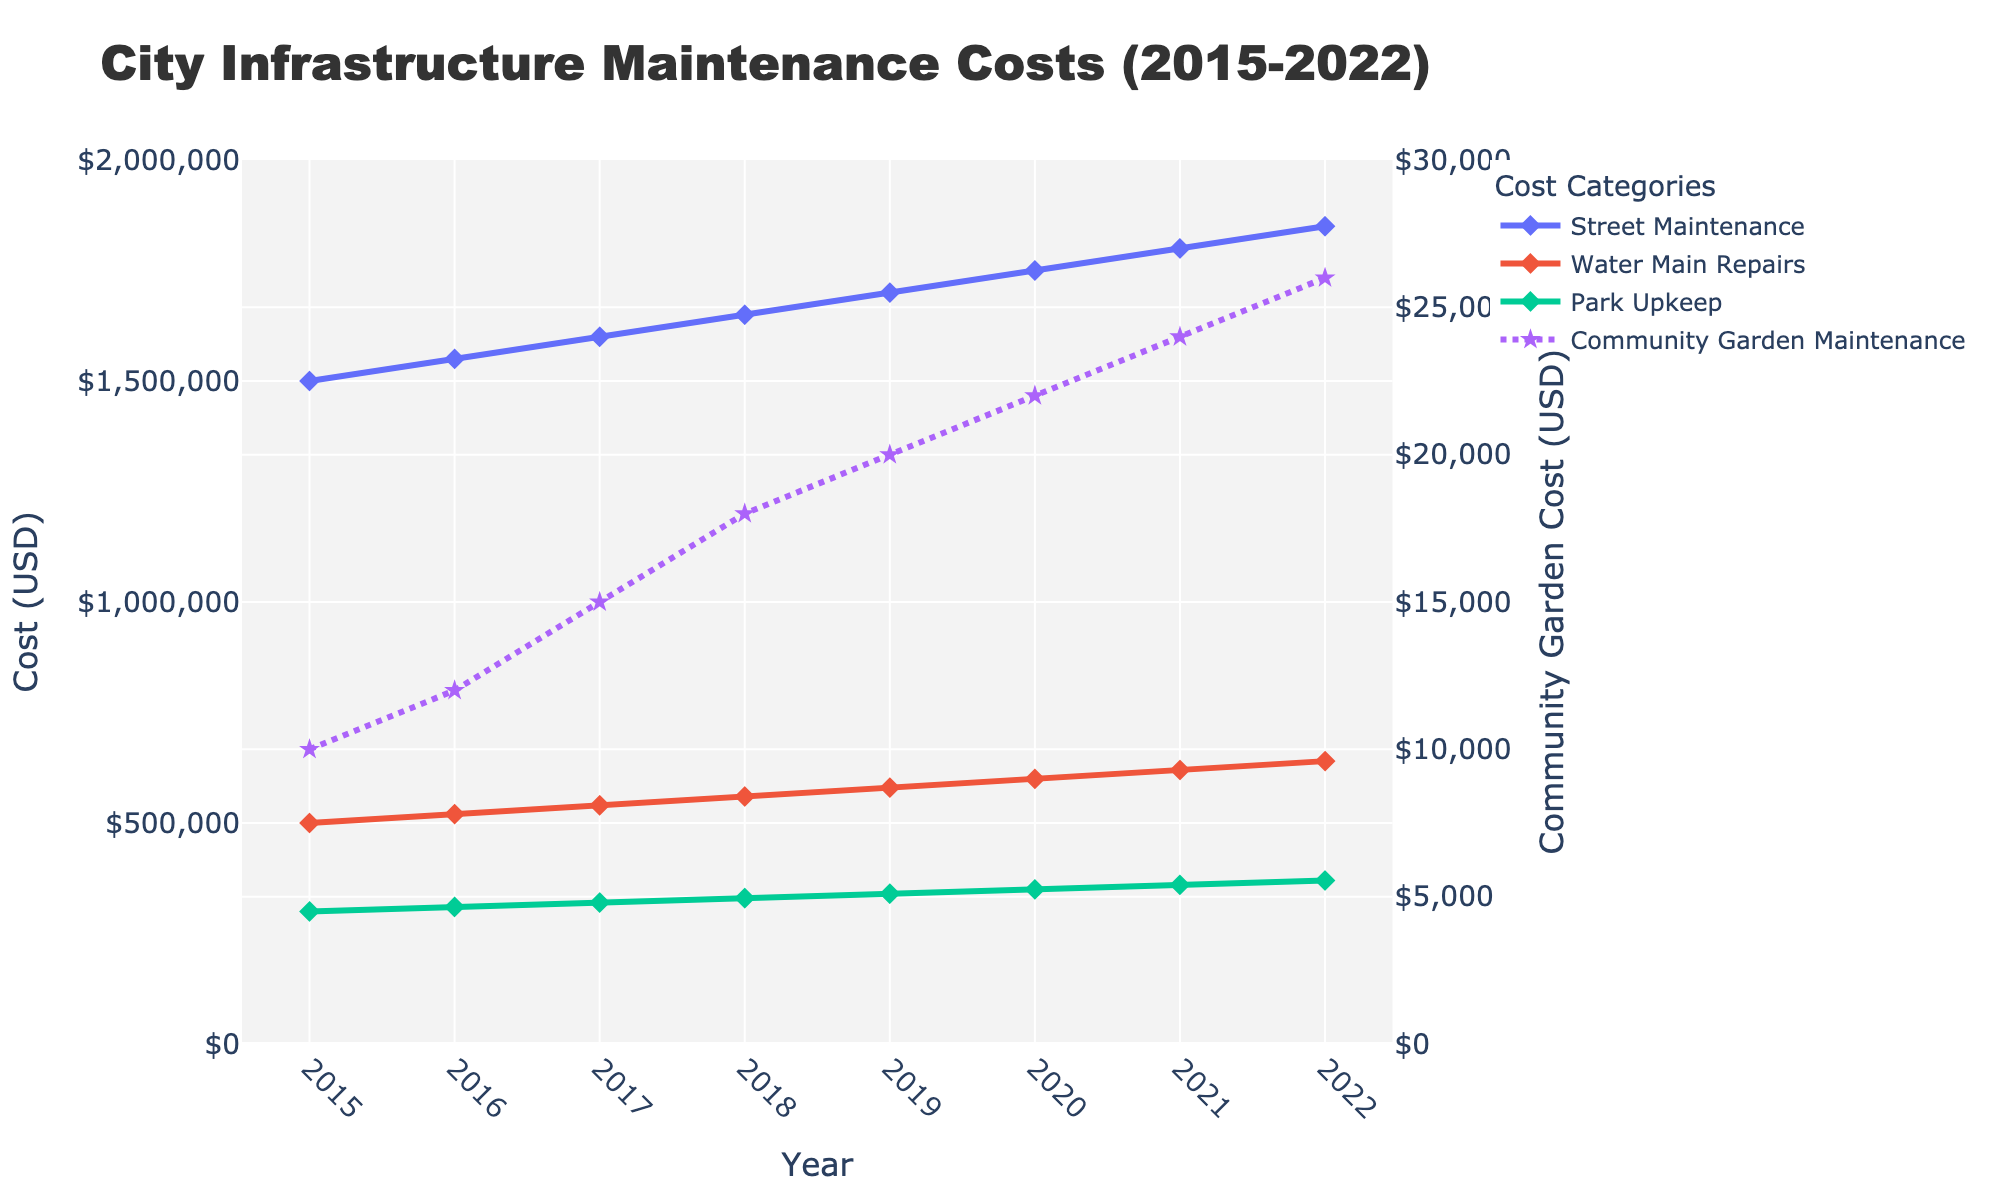what is the title of the chart? The title is displayed at the top of the chart. It reads "City Infrastructure Maintenance Costs (2015-2022)".
Answer: City Infrastructure Maintenance Costs (2015-2022) Which category had the lowest maintenance cost in 2020? The bottom data points in the chart correspond to Community Garden Maintenance, which has the lowest cost. In 2020, it had a cost just above the $20,000 line.
Answer: Community Garden Maintenance By how much did the Street Maintenance costs increase from 2015 to 2022? Referring to the chart, Street Maintenance costs in 2015 were $1,500,000 and this increased to $1,850,000 in 2022. The difference can be calculated as $1,850,000 - $1,500,000.
Answer: $350,000 What is the trend of Community Garden Maintenance costs from 2015 to 2022? Looking at the chart, Community Garden Maintenance costs show a steady upward trend, increasing each year.
Answer: Increasing How do the Park Upkeep costs in 2022 compare to Water Main Repairs costs in the same year? The chart shows that Park Upkeep costs in 2022 were $370,000, while Water Main Repairs costs were $640,000. Therefore, Water Main Repairs costs were significantly higher.
Answer: Water Main Repairs are higher Which year saw the largest year-over-year increase in Water Main Repairs costs, and by how much? By examining the chart, the largest increase was from 2020 to 2021. In 2020, costs were $600,000 and they rose to $620,000 in 2021. The difference is $20,000.
Answer: 2021, by $20,000 What is the average Park Upkeep cost over the years shown in the chart? The data points for Park Upkeep from 2015 to 2022 give us the following values: $300,000, $310,000, $320,000, $330,000, $340,000, $350,000, $360,000, $370,000. Calculating the sum, we get $2,680,000. Dividing by the 8 years gives us an average. $2,680,000 / 8 = $335,000.
Answer: $335,000 How do Street Maintenance and Park Upkeep costs compare in 2017? Referring to the chart, in 2017, Street Maintenance costs were $1,600,000 and Park Upkeep were $320,000. Street Maintenance costs were much higher than Park Upkeep costs.
Answer: Street Maintenance is much higher What is the difference between the highest and the lowest Community Garden Maintenance cost over the years? The highest value in 2022 was $26,000 and the lowest in 2015 was $10,000. The difference can be calculated as $26,000 - $10,000.
Answer: $16,000 How does the trend of Street Maintenance compare to Water Main Repairs over the years? Both Street Maintenance and Water Main Repairs costs show an upward trend over the years, with Street Maintenance costs consistently being higher than Water Main Repairs.
Answer: Upward trend, Street Maintenance higher 